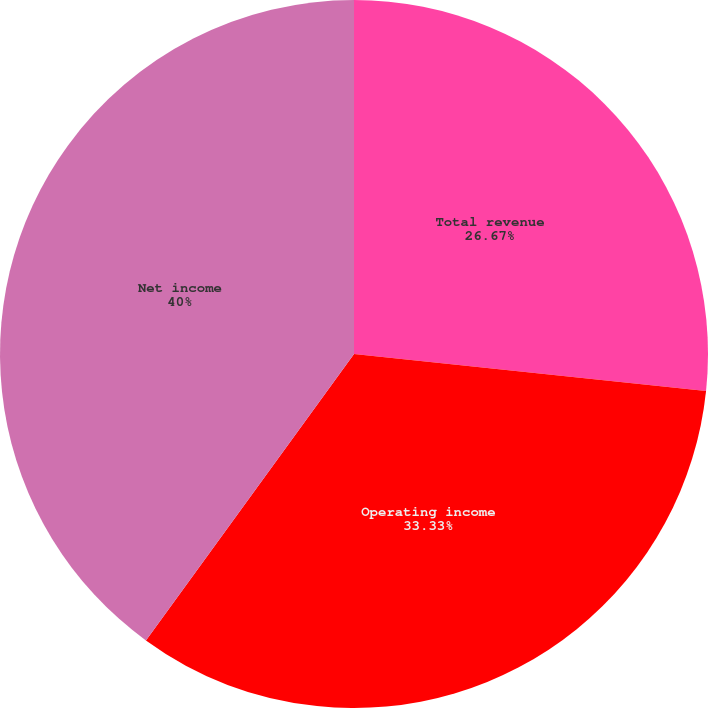Convert chart. <chart><loc_0><loc_0><loc_500><loc_500><pie_chart><fcel>Total revenue<fcel>Operating income<fcel>Net income<nl><fcel>26.67%<fcel>33.33%<fcel>40.0%<nl></chart> 